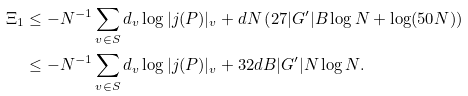<formula> <loc_0><loc_0><loc_500><loc_500>\Xi _ { 1 } & \leq - N ^ { - 1 } \sum _ { v \in S } d _ { v } \log | j ( P ) | _ { v } + d N \left ( 2 7 | G ^ { \prime } | B \log N + \log ( 5 0 N ) \right ) \\ & \leq - N ^ { - 1 } \sum _ { v \in S } d _ { v } \log | j ( P ) | _ { v } + 3 2 d B | G ^ { \prime } | N \log N .</formula> 